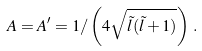<formula> <loc_0><loc_0><loc_500><loc_500>A = A ^ { \prime } = 1 / \left ( 4 \sqrt { \tilde { l } ( \tilde { l } + 1 ) } \right ) \, .</formula> 